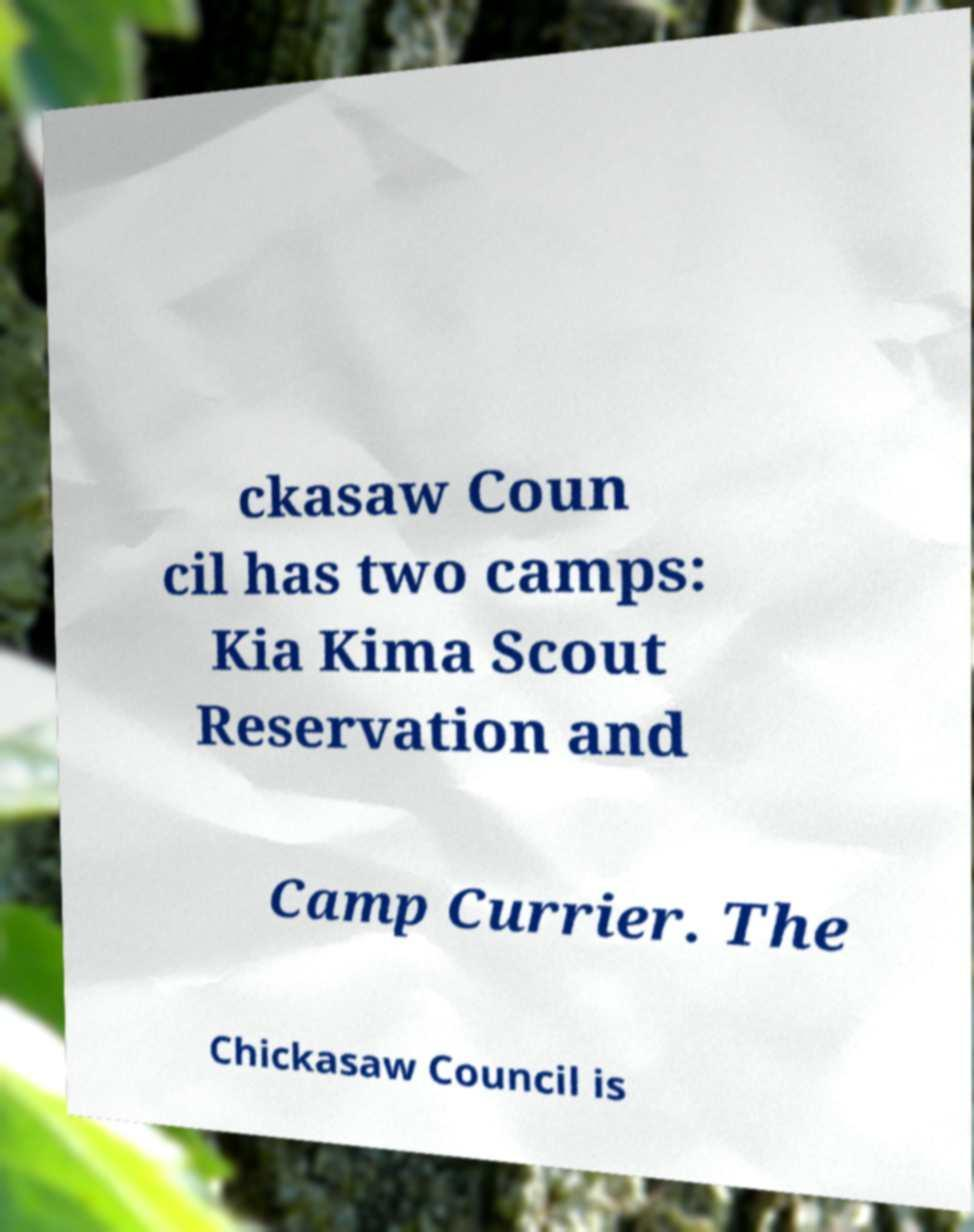Can you read and provide the text displayed in the image?This photo seems to have some interesting text. Can you extract and type it out for me? ckasaw Coun cil has two camps: Kia Kima Scout Reservation and Camp Currier. The Chickasaw Council is 